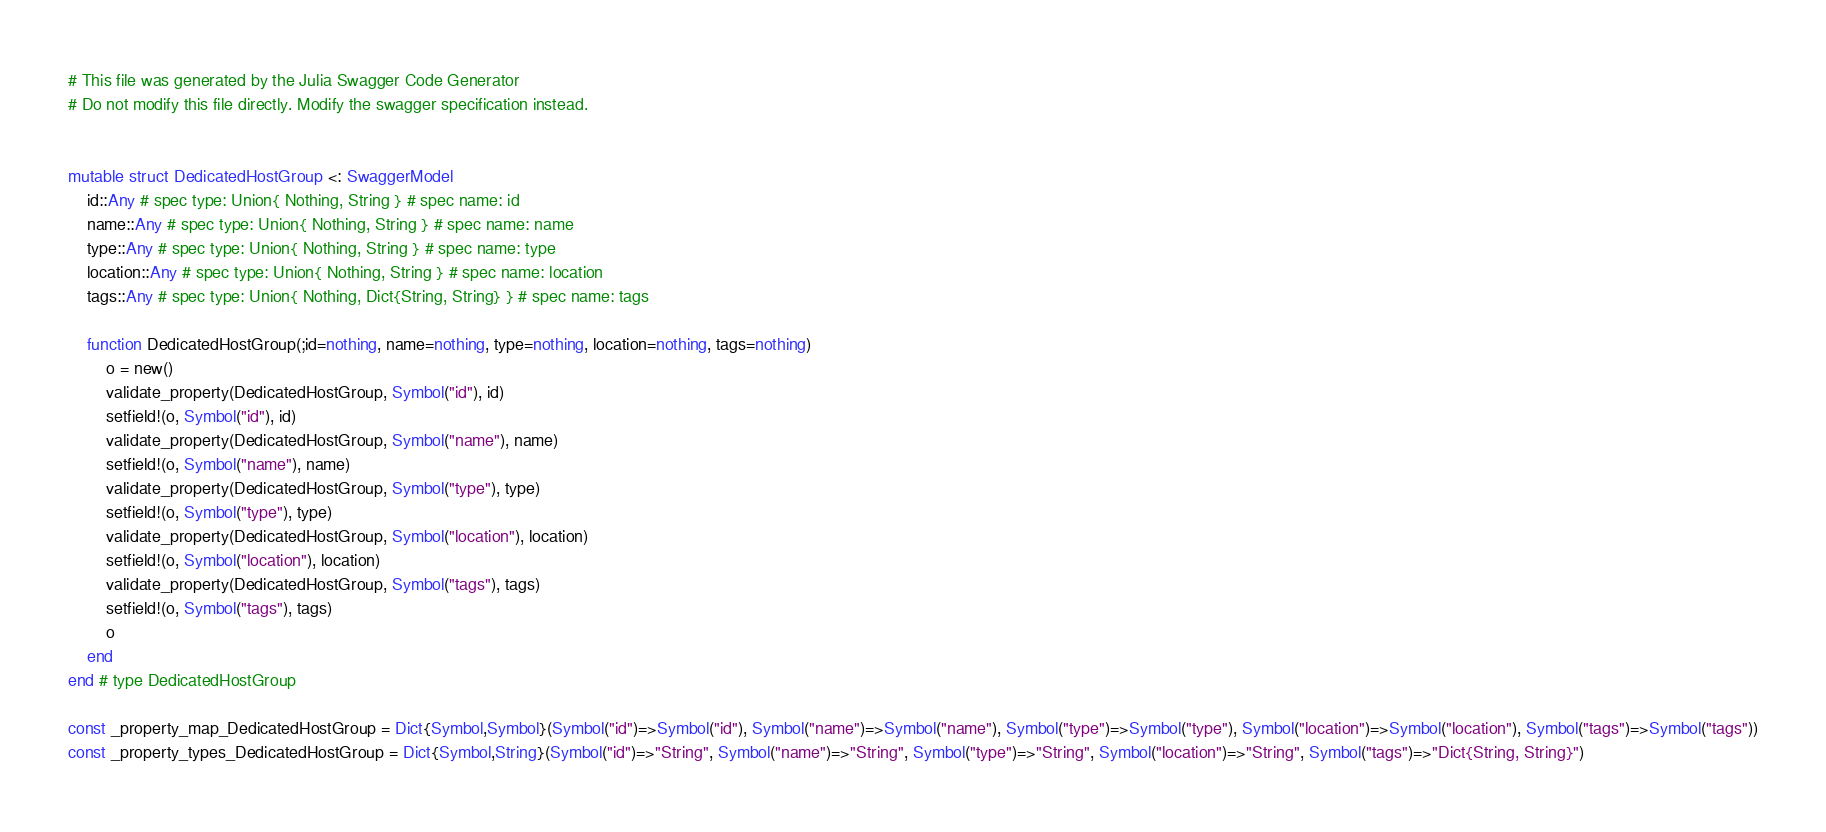<code> <loc_0><loc_0><loc_500><loc_500><_Julia_># This file was generated by the Julia Swagger Code Generator
# Do not modify this file directly. Modify the swagger specification instead.


mutable struct DedicatedHostGroup <: SwaggerModel
    id::Any # spec type: Union{ Nothing, String } # spec name: id
    name::Any # spec type: Union{ Nothing, String } # spec name: name
    type::Any # spec type: Union{ Nothing, String } # spec name: type
    location::Any # spec type: Union{ Nothing, String } # spec name: location
    tags::Any # spec type: Union{ Nothing, Dict{String, String} } # spec name: tags

    function DedicatedHostGroup(;id=nothing, name=nothing, type=nothing, location=nothing, tags=nothing)
        o = new()
        validate_property(DedicatedHostGroup, Symbol("id"), id)
        setfield!(o, Symbol("id"), id)
        validate_property(DedicatedHostGroup, Symbol("name"), name)
        setfield!(o, Symbol("name"), name)
        validate_property(DedicatedHostGroup, Symbol("type"), type)
        setfield!(o, Symbol("type"), type)
        validate_property(DedicatedHostGroup, Symbol("location"), location)
        setfield!(o, Symbol("location"), location)
        validate_property(DedicatedHostGroup, Symbol("tags"), tags)
        setfield!(o, Symbol("tags"), tags)
        o
    end
end # type DedicatedHostGroup

const _property_map_DedicatedHostGroup = Dict{Symbol,Symbol}(Symbol("id")=>Symbol("id"), Symbol("name")=>Symbol("name"), Symbol("type")=>Symbol("type"), Symbol("location")=>Symbol("location"), Symbol("tags")=>Symbol("tags"))
const _property_types_DedicatedHostGroup = Dict{Symbol,String}(Symbol("id")=>"String", Symbol("name")=>"String", Symbol("type")=>"String", Symbol("location")=>"String", Symbol("tags")=>"Dict{String, String}")</code> 